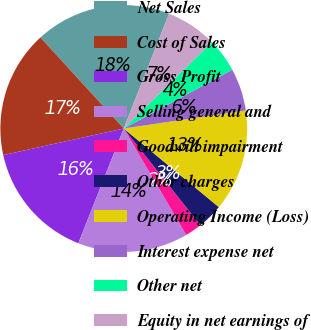Convert chart. <chart><loc_0><loc_0><loc_500><loc_500><pie_chart><fcel>Net Sales<fcel>Cost of Sales<fcel>Gross Profit<fcel>Selling general and<fcel>Goodwill impairment<fcel>Other charges<fcel>Operating Income (Loss)<fcel>Interest expense net<fcel>Other net<fcel>Equity in net earnings of<nl><fcel>17.78%<fcel>16.66%<fcel>15.55%<fcel>14.44%<fcel>2.22%<fcel>3.34%<fcel>13.33%<fcel>5.56%<fcel>4.45%<fcel>6.67%<nl></chart> 